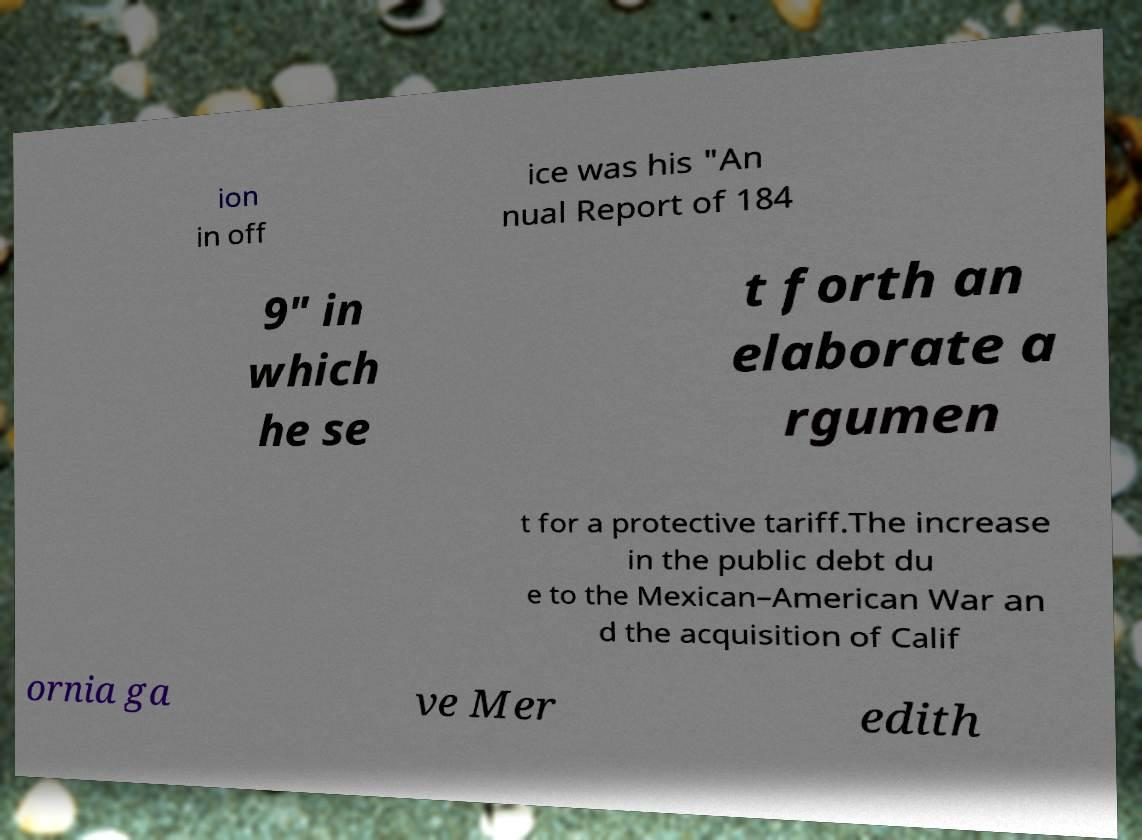Please identify and transcribe the text found in this image. ion in off ice was his "An nual Report of 184 9" in which he se t forth an elaborate a rgumen t for a protective tariff.The increase in the public debt du e to the Mexican–American War an d the acquisition of Calif ornia ga ve Mer edith 